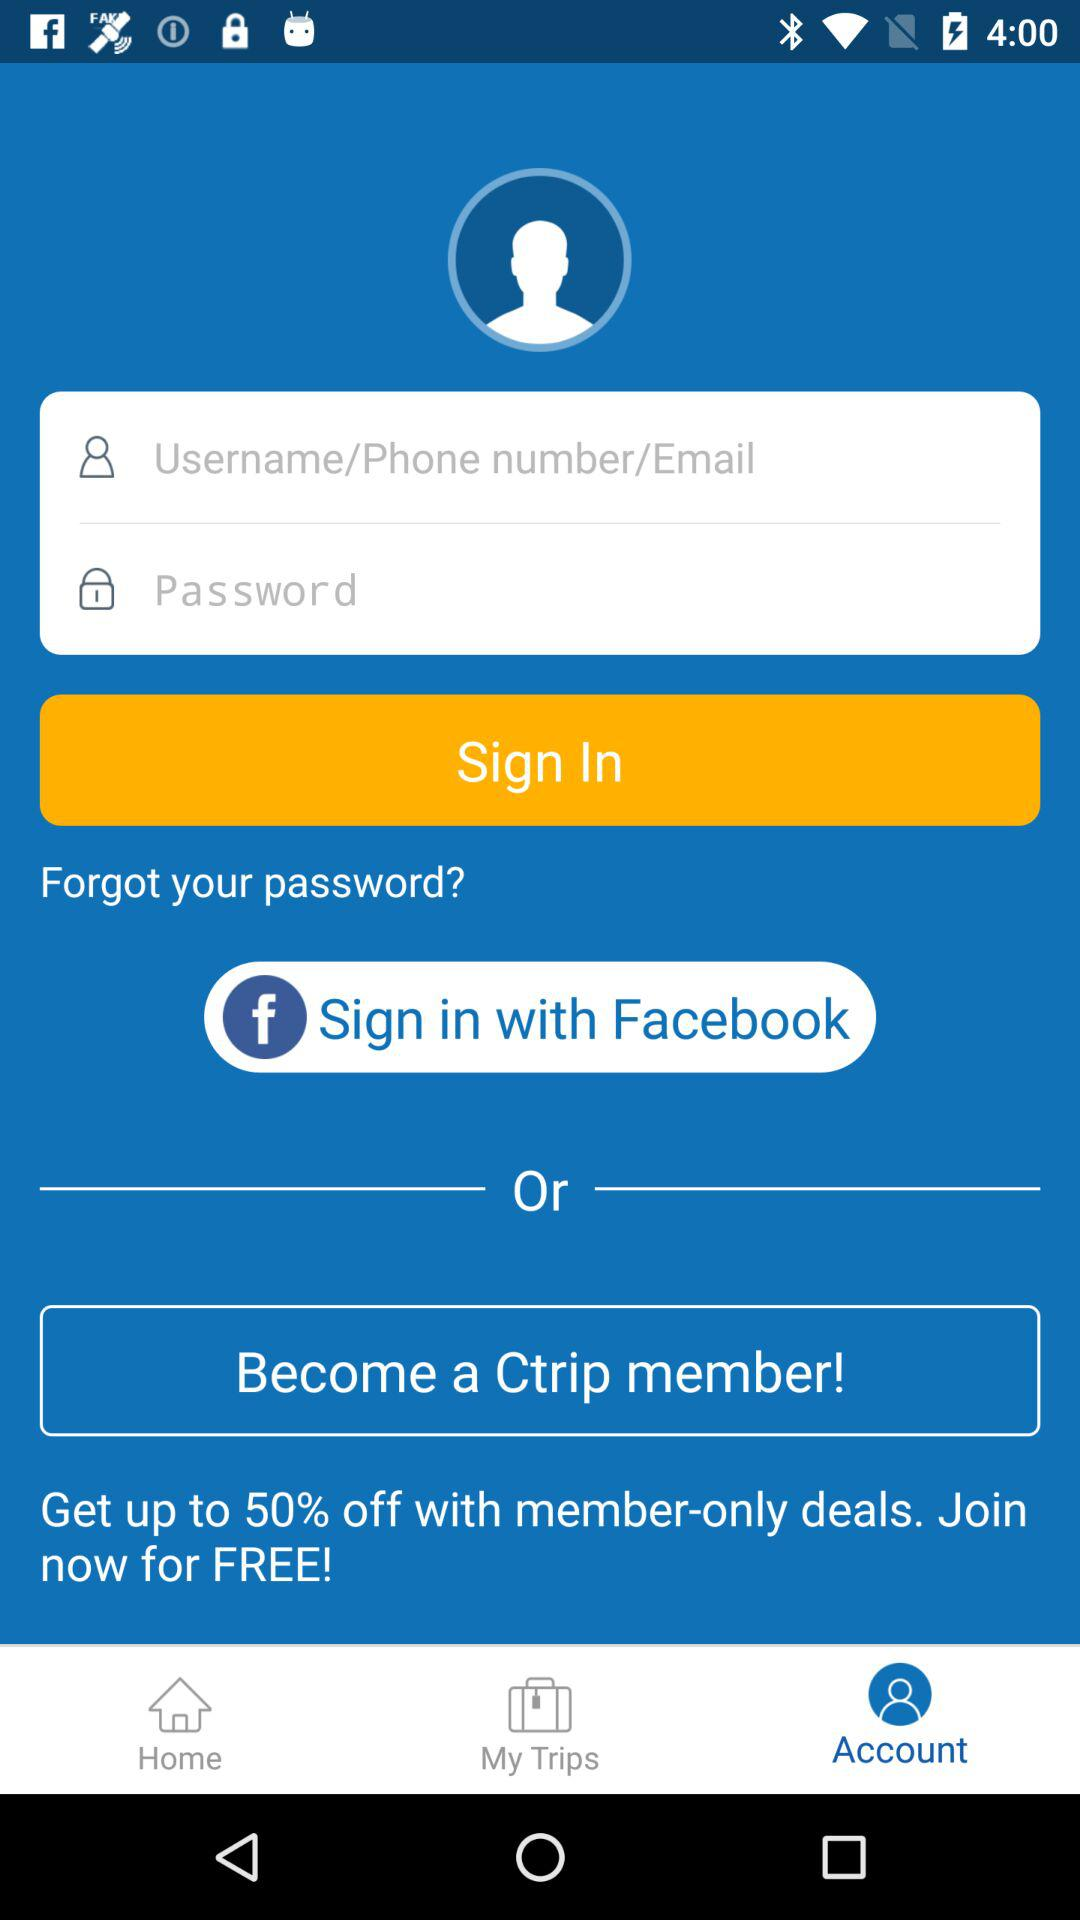How many characters are required to create a password?
When the provided information is insufficient, respond with <no answer>. <no answer> 